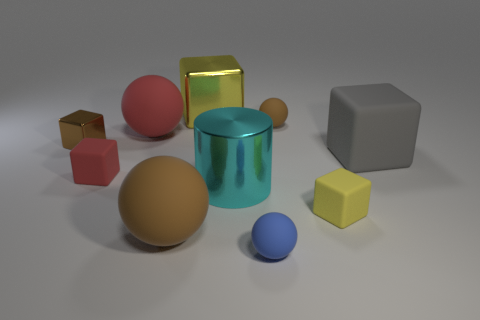Subtract all gray cubes. How many cubes are left? 4 Subtract all big gray cubes. How many cubes are left? 4 Subtract all cyan blocks. Subtract all brown cylinders. How many blocks are left? 5 Subtract all cylinders. How many objects are left? 9 Subtract all gray metal things. Subtract all tiny yellow cubes. How many objects are left? 9 Add 4 big things. How many big things are left? 9 Add 1 cyan cylinders. How many cyan cylinders exist? 2 Subtract 0 purple blocks. How many objects are left? 10 